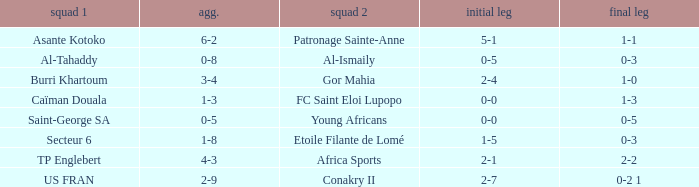What was the 2nd leg score between Patronage Sainte-Anne and Asante Kotoko? 1-1. 